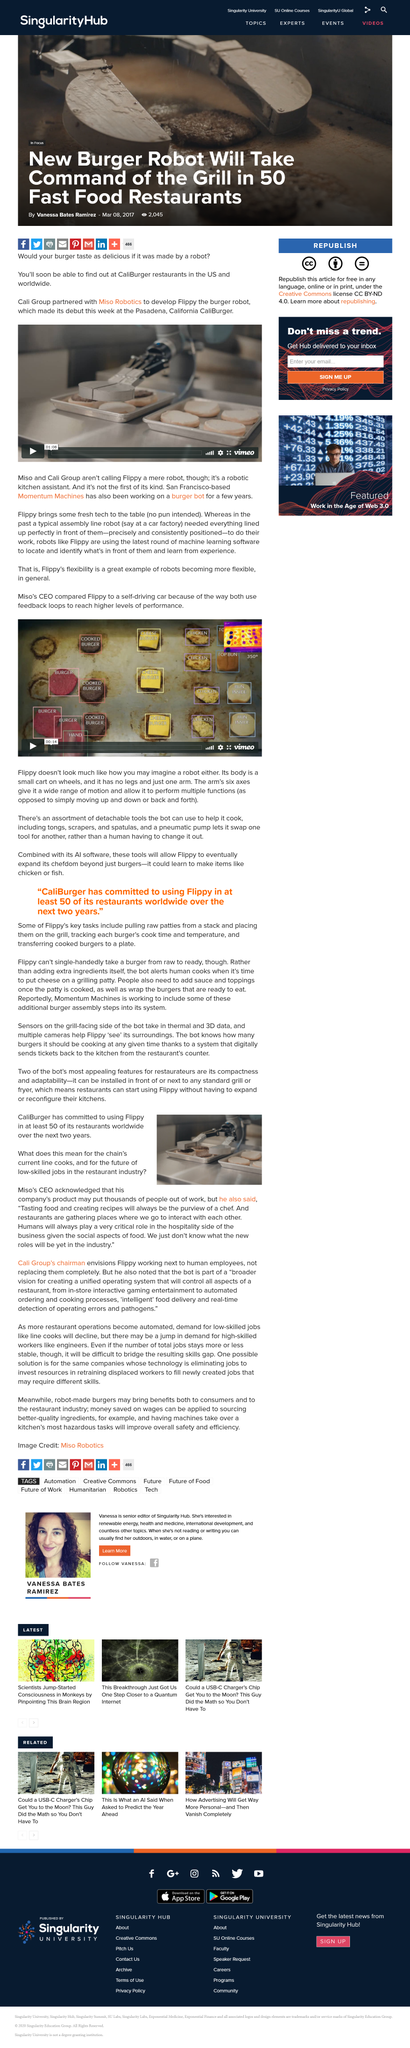Give some essential details in this illustration. Momentum Machines, a San Francisco-based company, has been working on a burger bot for several years. The purview of a chef is to taste food and create recipes, which is an inherent and indispensable aspect of their profession. The Flippy is not just a robot but a robotic kitchen assistant that is not to be underestimated. It is a versatile and advanced kitchen helper that has the capability to perform complex tasks with ease, making it a valuable asset to any kitchen. Flippy, a robot kitchen assistant, employs the latest round of machine learning software to locate and identify objects in front of it and learn from its experiences. The hospitality side of the restaurant business will always require human involvement due to the crucial role that social interactions play in the enjoyment of food. 